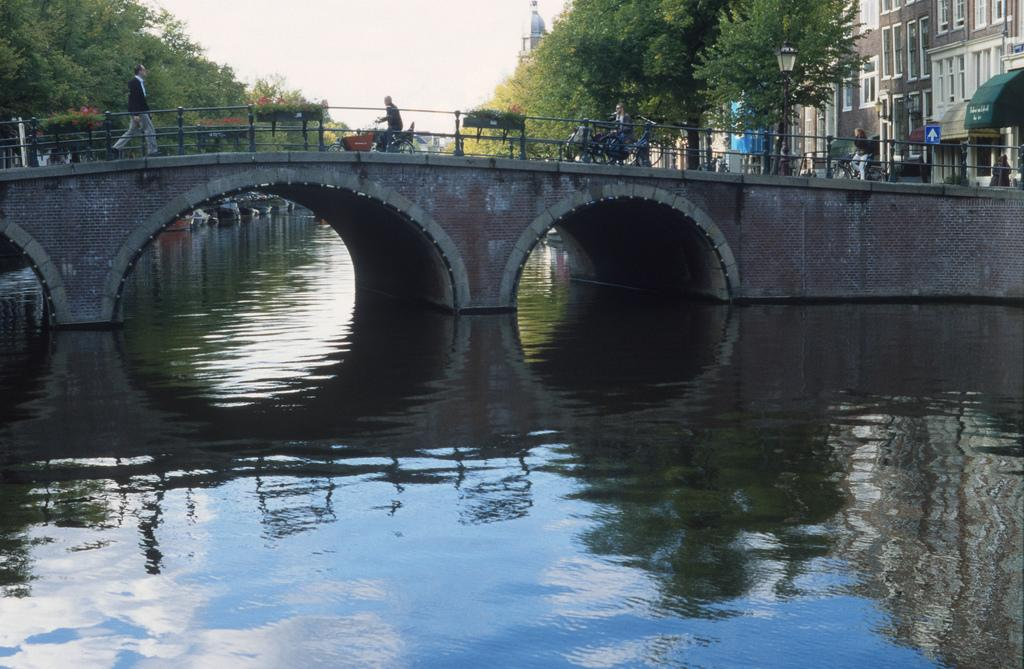What type of natural feature is present in the image? There is a river in the image. What structure can be seen crossing the river? There is a bridge in the image. Are there any people in the image? Yes, there are people in the image. What are the people doing on the bridge? The people are riding bicycles on the bridge. What type of vegetation is present in the image? There are trees in the image. What type of man-made structures can be seen in the image? There are buildings in the image. What is visible in the sky in the image? The sky is visible in the image. What type of beef can be seen hanging from the bridge in the image? There is no beef present in the image; it features a river, a bridge, people, bicycles, trees, buildings, and a visible sky. What advice is being given to the people on the bicycles in the image? There is no indication in the image that any advice is being given to the people on the bicycles. 